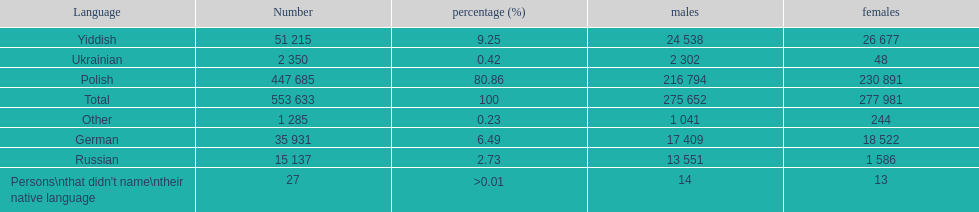How many people didn't name their native language? 27. 